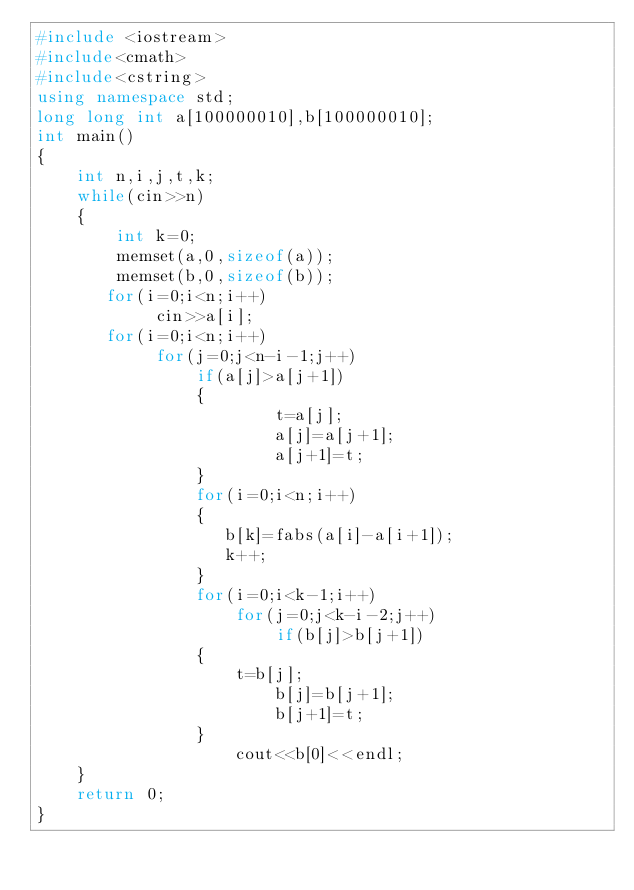Convert code to text. <code><loc_0><loc_0><loc_500><loc_500><_C++_>#include <iostream>
#include<cmath>
#include<cstring>
using namespace std;
long long int a[100000010],b[100000010];
int main()
{
    int n,i,j,t,k;
    while(cin>>n)
    {
        int k=0;
        memset(a,0,sizeof(a));
        memset(b,0,sizeof(b));
       for(i=0;i<n;i++)
            cin>>a[i];
       for(i=0;i<n;i++)
            for(j=0;j<n-i-1;j++)
                if(a[j]>a[j+1])
                {
                        t=a[j];
                        a[j]=a[j+1];
                        a[j+1]=t;
                }
                for(i=0;i<n;i++)
                {
                   b[k]=fabs(a[i]-a[i+1]);
                   k++;
                }
                for(i=0;i<k-1;i++)
                    for(j=0;j<k-i-2;j++)
                        if(b[j]>b[j+1])
                {
                    t=b[j];
                        b[j]=b[j+1];
                        b[j+1]=t;
                }
                    cout<<b[0]<<endl;
    }
    return 0;
}</code> 